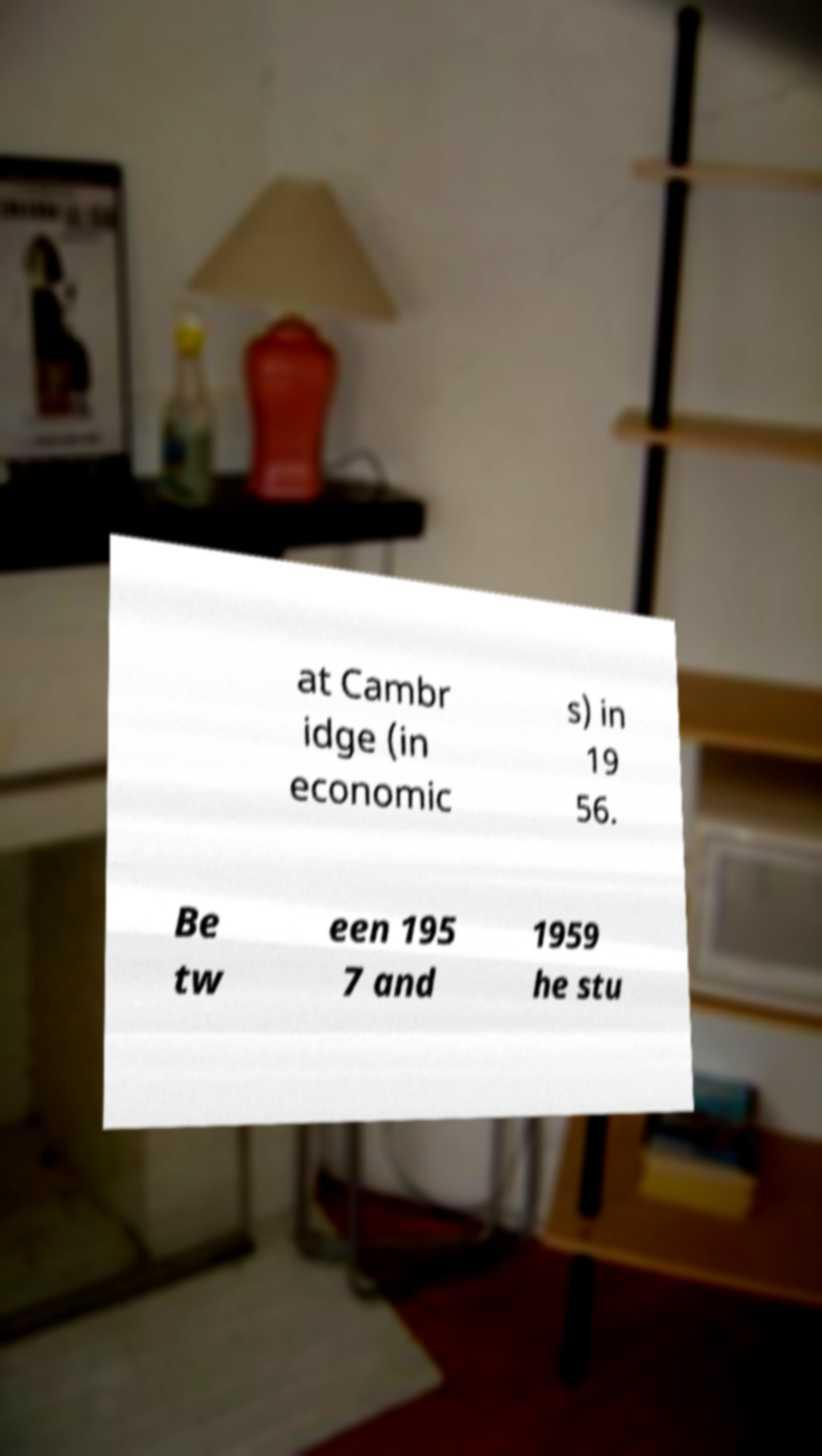Please identify and transcribe the text found in this image. at Cambr idge (in economic s) in 19 56. Be tw een 195 7 and 1959 he stu 